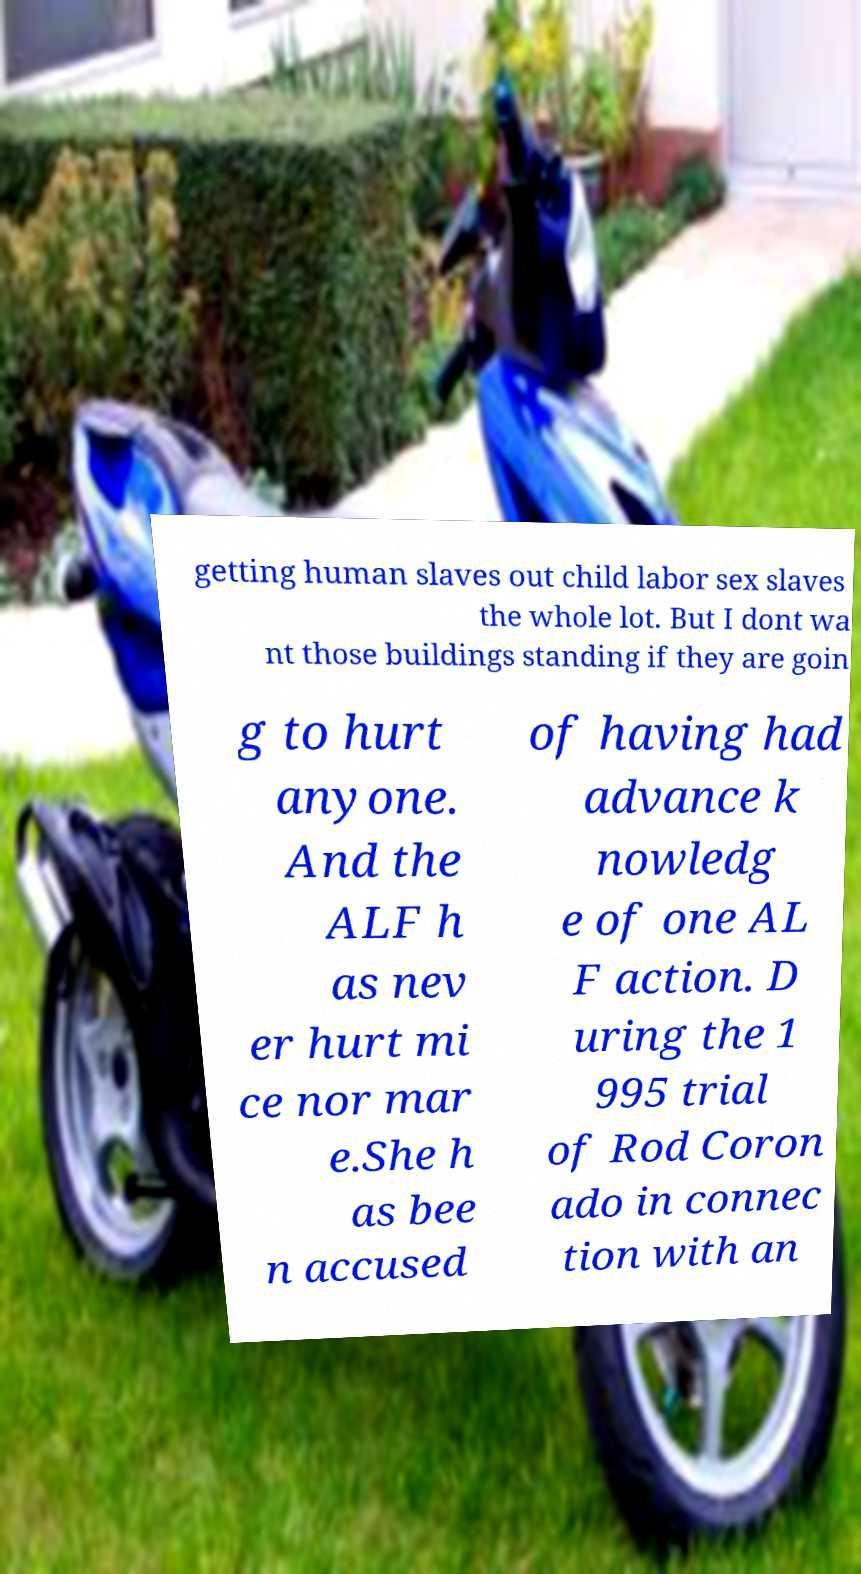Can you accurately transcribe the text from the provided image for me? getting human slaves out child labor sex slaves the whole lot. But I dont wa nt those buildings standing if they are goin g to hurt anyone. And the ALF h as nev er hurt mi ce nor mar e.She h as bee n accused of having had advance k nowledg e of one AL F action. D uring the 1 995 trial of Rod Coron ado in connec tion with an 